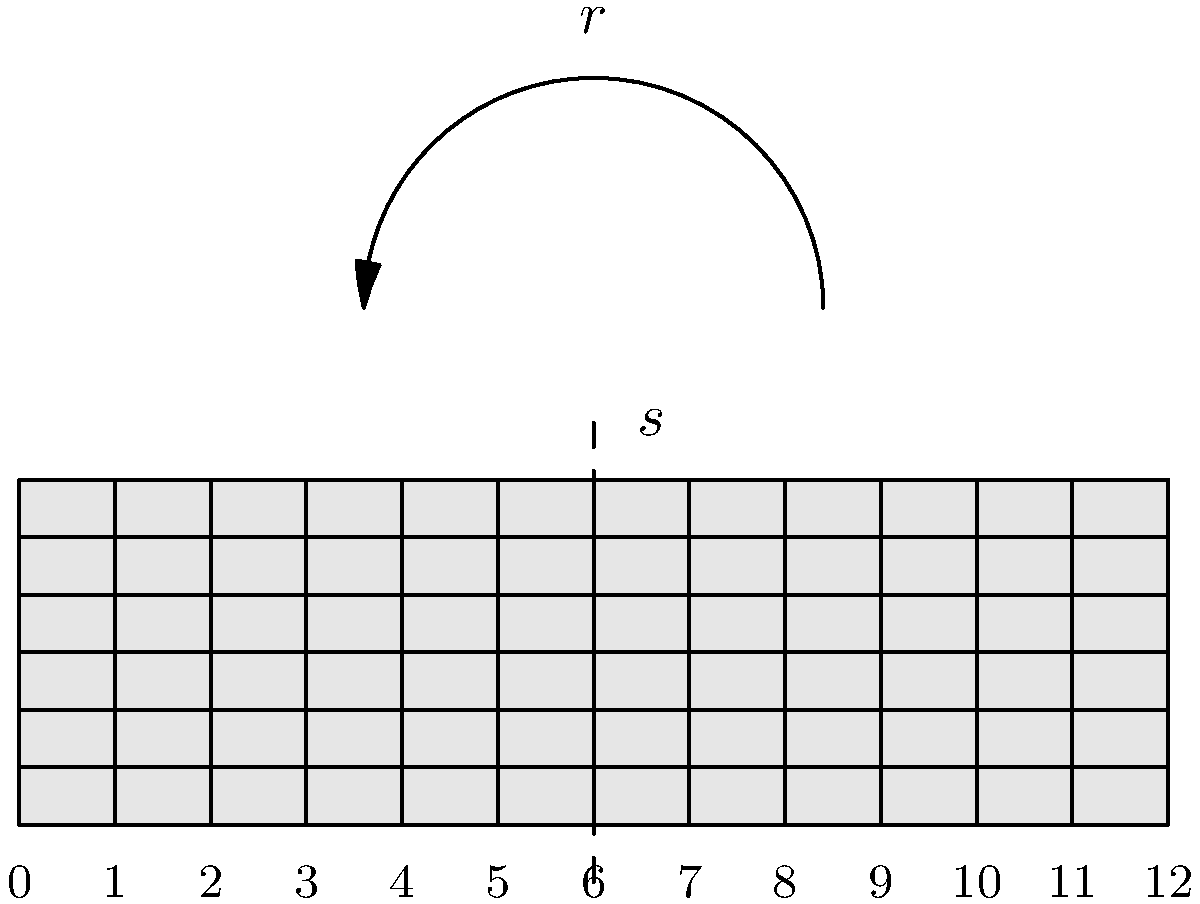On a rare Guns N' Roses album cover, you notice a stylized guitar fretboard diagram. The fretboard pattern exhibits symmetries that form a dihedral group $D_{12}$. If $r$ represents a clockwise rotation by 30° and $s$ represents a reflection across the 6th fret, what is the result of the group operation $rs^2r$? Let's break this down step-by-step:

1) In the dihedral group $D_{12}$, we have:
   - 12 rotations (including the identity)
   - 12 reflections

2) $r$ represents a clockwise rotation by 30°, which is equivalent to moving one fret to the right.

3) $s$ represents a reflection across the 6th fret.

4) We need to evaluate $rs^2r$ from right to left:

   a) First $r$: Rotate clockwise by 30° (move one fret right)
   b) Then $s^2$: Reflect twice across the 6th fret. Two reflections cancel out, so this is equivalent to the identity operation.
   c) Finally, another $r$: Rotate clockwise by 30° again (move one more fret right)

5) The net result is two clockwise rotations of 30° each, which is equivalent to a single clockwise rotation of 60°.

6) In group theory notation, this is equivalent to $r^2$.

Therefore, the result of the group operation $rs^2r$ is $r^2$, which represents a clockwise rotation by 60°.
Answer: $r^2$ 